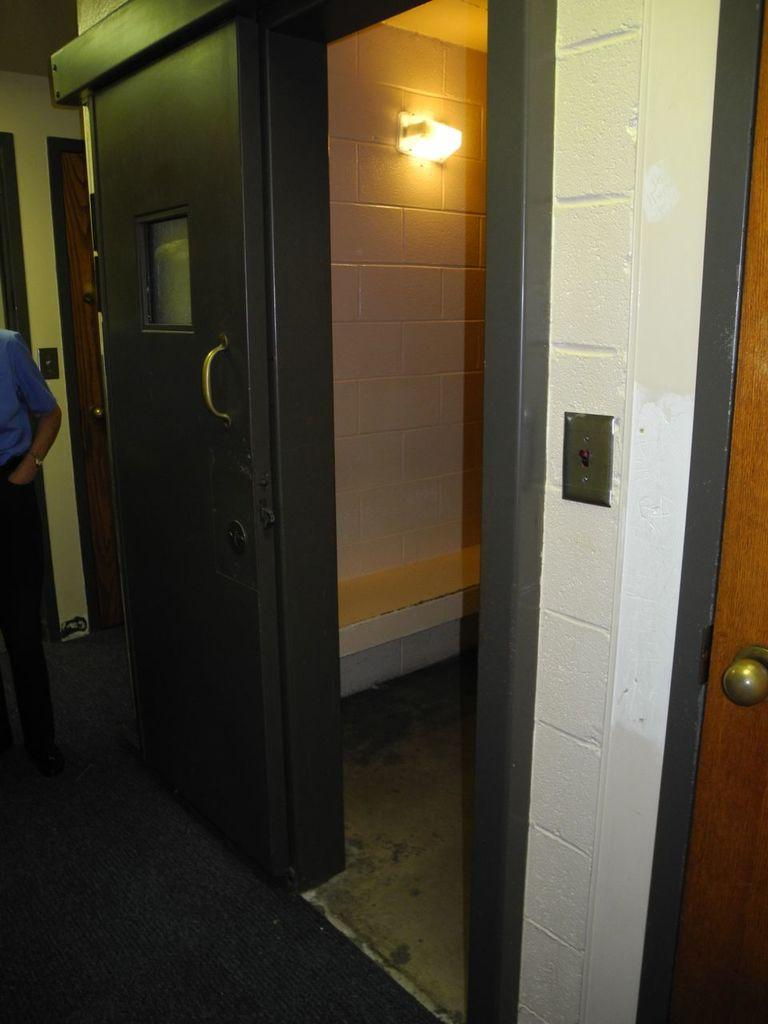What type of space is depicted in the image? There is a room in the image. Where is the door located in the room? The door is on the left side of the room. Who or what is present in the room? There is a person in the room. What can be seen in the background of the room? Tiles and a light are present in the background of the room. What type of shock can be seen on the person's face in the image? There is no shock visible on the person's face in the image. 